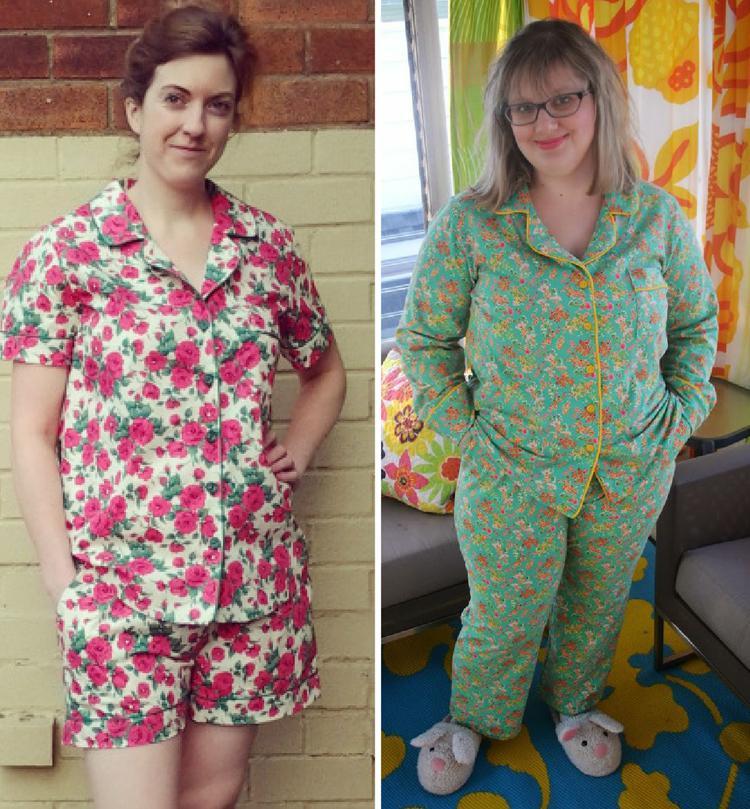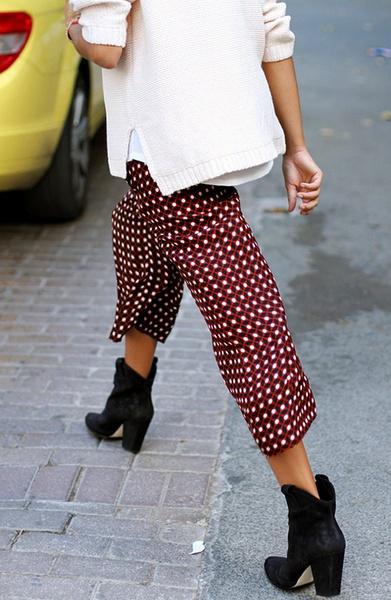The first image is the image on the left, the second image is the image on the right. Evaluate the accuracy of this statement regarding the images: "The lefthand image shows a pair of pajama-clad models in side-by-side views.". Is it true? Answer yes or no. Yes. 